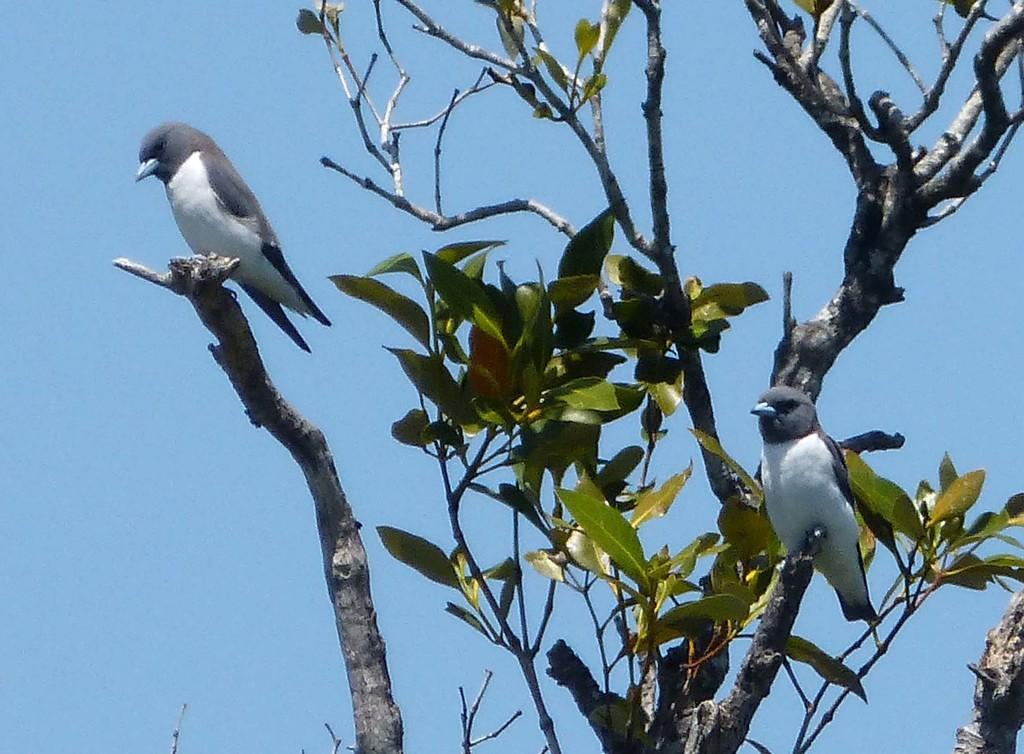What type of animals can be seen in the image? Birds can be seen in the image. Where are the birds located in the image? The birds are standing on the branch of a tree. What is the position of the tree in the image? The tree is in the front of the image. What type of industry can be seen in the background of the image? There is no industry visible in the image; it features birds on a tree branch. What creature is hanging from the branch of the tree in the image? There are no creatures hanging from the branch of the tree in the image; only birds are present. 